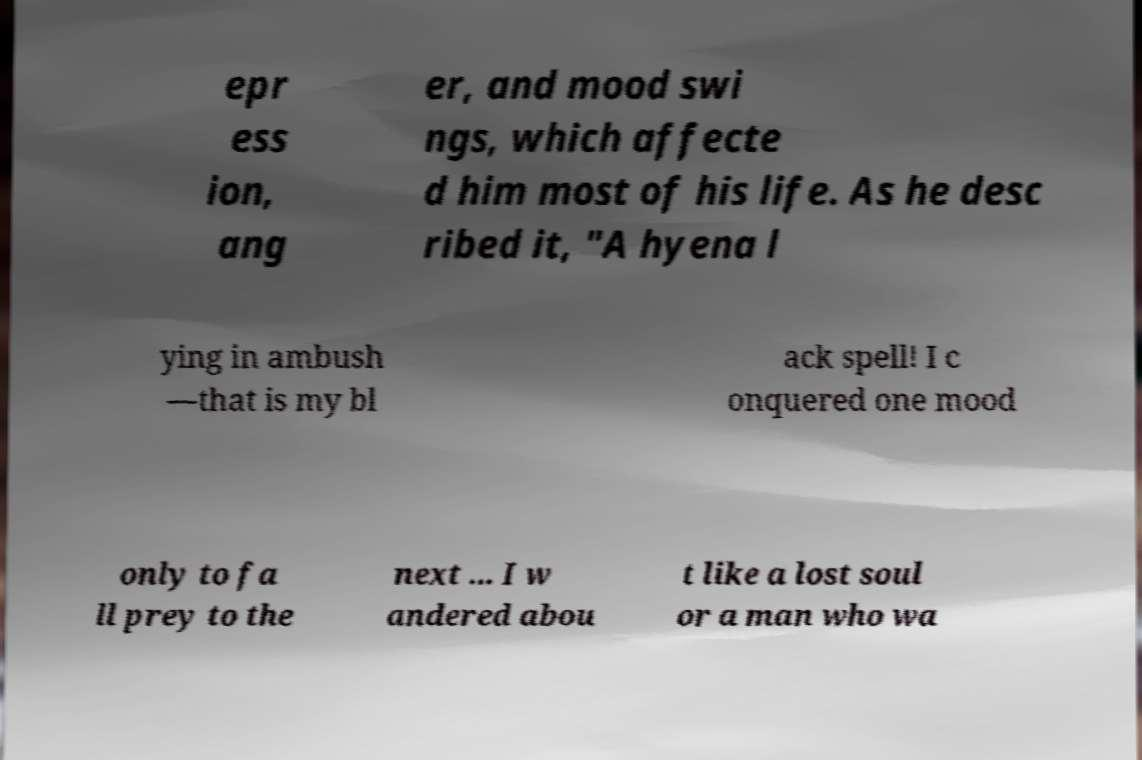Can you accurately transcribe the text from the provided image for me? epr ess ion, ang er, and mood swi ngs, which affecte d him most of his life. As he desc ribed it, "A hyena l ying in ambush —that is my bl ack spell! I c onquered one mood only to fa ll prey to the next ... I w andered abou t like a lost soul or a man who wa 